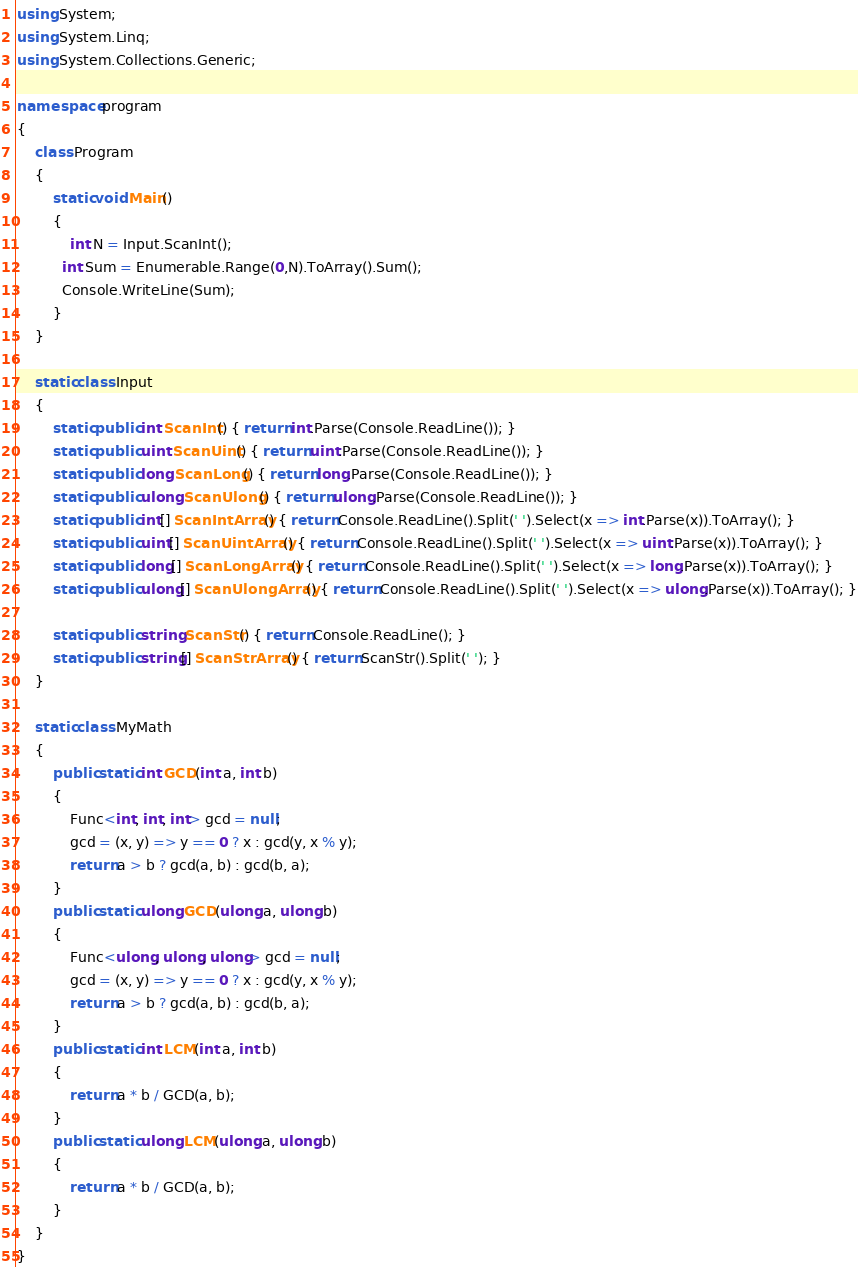Convert code to text. <code><loc_0><loc_0><loc_500><loc_500><_C#_>using System;
using System.Linq;
using System.Collections.Generic;

namespace program
{
    class Program
    {
        static void Main()
        {
            int N = Input.ScanInt();
          int Sum = Enumerable.Range(0,N).ToArray().Sum();
          Console.WriteLine(Sum);
        }
    }

    static class Input
    {
        static public int ScanInt() { return int.Parse(Console.ReadLine()); }
        static public uint ScanUint() { return uint.Parse(Console.ReadLine()); }
        static public long ScanLong() { return long.Parse(Console.ReadLine()); }
        static public ulong ScanUlong() { return ulong.Parse(Console.ReadLine()); }
        static public int[] ScanIntArray() { return Console.ReadLine().Split(' ').Select(x => int.Parse(x)).ToArray(); }
        static public uint[] ScanUintArray() { return Console.ReadLine().Split(' ').Select(x => uint.Parse(x)).ToArray(); }
        static public long[] ScanLongArray() { return Console.ReadLine().Split(' ').Select(x => long.Parse(x)).ToArray(); }
        static public ulong[] ScanUlongArray() { return Console.ReadLine().Split(' ').Select(x => ulong.Parse(x)).ToArray(); }

        static public string ScanStr() { return Console.ReadLine(); }
        static public string[] ScanStrArray() { return ScanStr().Split(' '); }
    }

    static class MyMath
    {
        public static int GCD(int a, int b)
        {
            Func<int, int, int> gcd = null;
            gcd = (x, y) => y == 0 ? x : gcd(y, x % y);
            return a > b ? gcd(a, b) : gcd(b, a);
        }
        public static ulong GCD(ulong a, ulong b)
        {
            Func<ulong, ulong, ulong> gcd = null;
            gcd = (x, y) => y == 0 ? x : gcd(y, x % y);
            return a > b ? gcd(a, b) : gcd(b, a);
        }
        public static int LCM(int a, int b)
        {
            return a * b / GCD(a, b);
        }
        public static ulong LCM(ulong a, ulong b)
        {
            return a * b / GCD(a, b);
        }
    }
}
</code> 